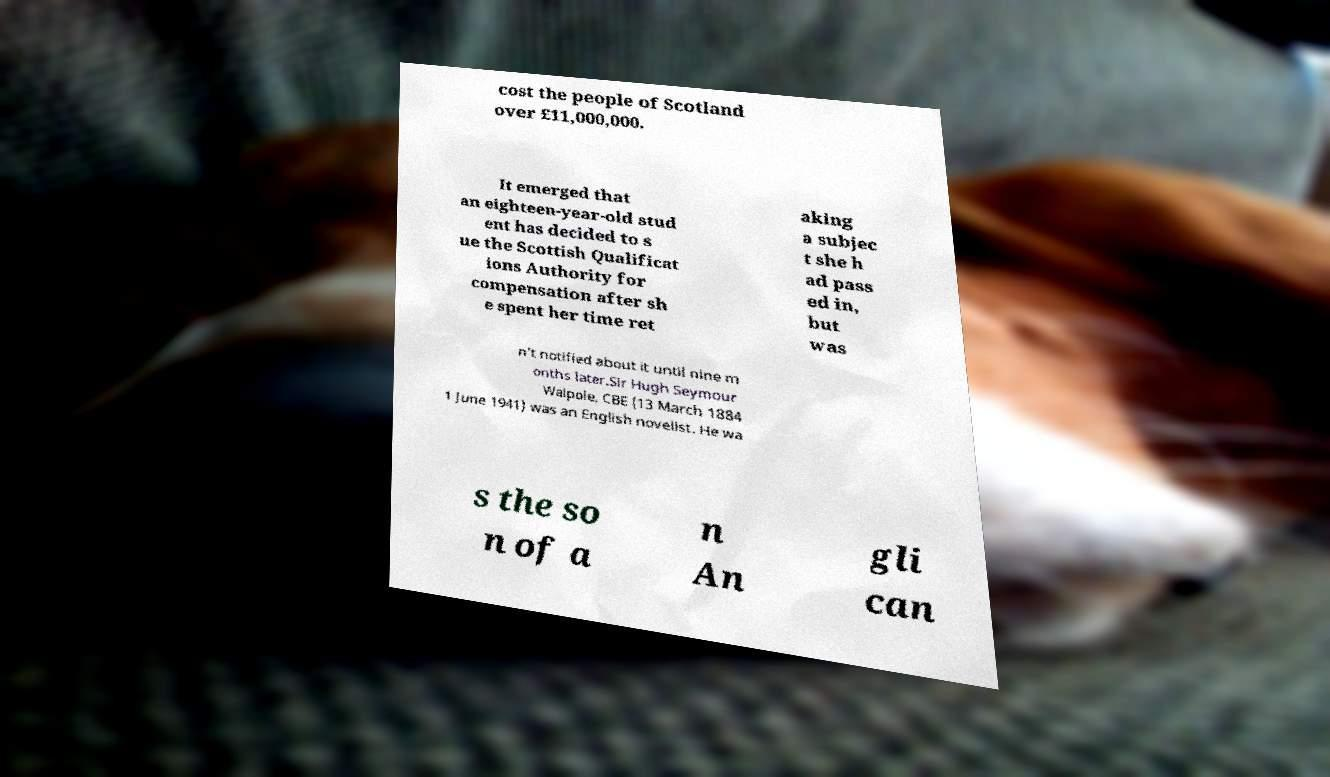Please identify and transcribe the text found in this image. cost the people of Scotland over £11,000,000. It emerged that an eighteen-year-old stud ent has decided to s ue the Scottish Qualificat ions Authority for compensation after sh e spent her time ret aking a subjec t she h ad pass ed in, but was n't notified about it until nine m onths later.Sir Hugh Seymour Walpole, CBE (13 March 1884 1 June 1941) was an English novelist. He wa s the so n of a n An gli can 